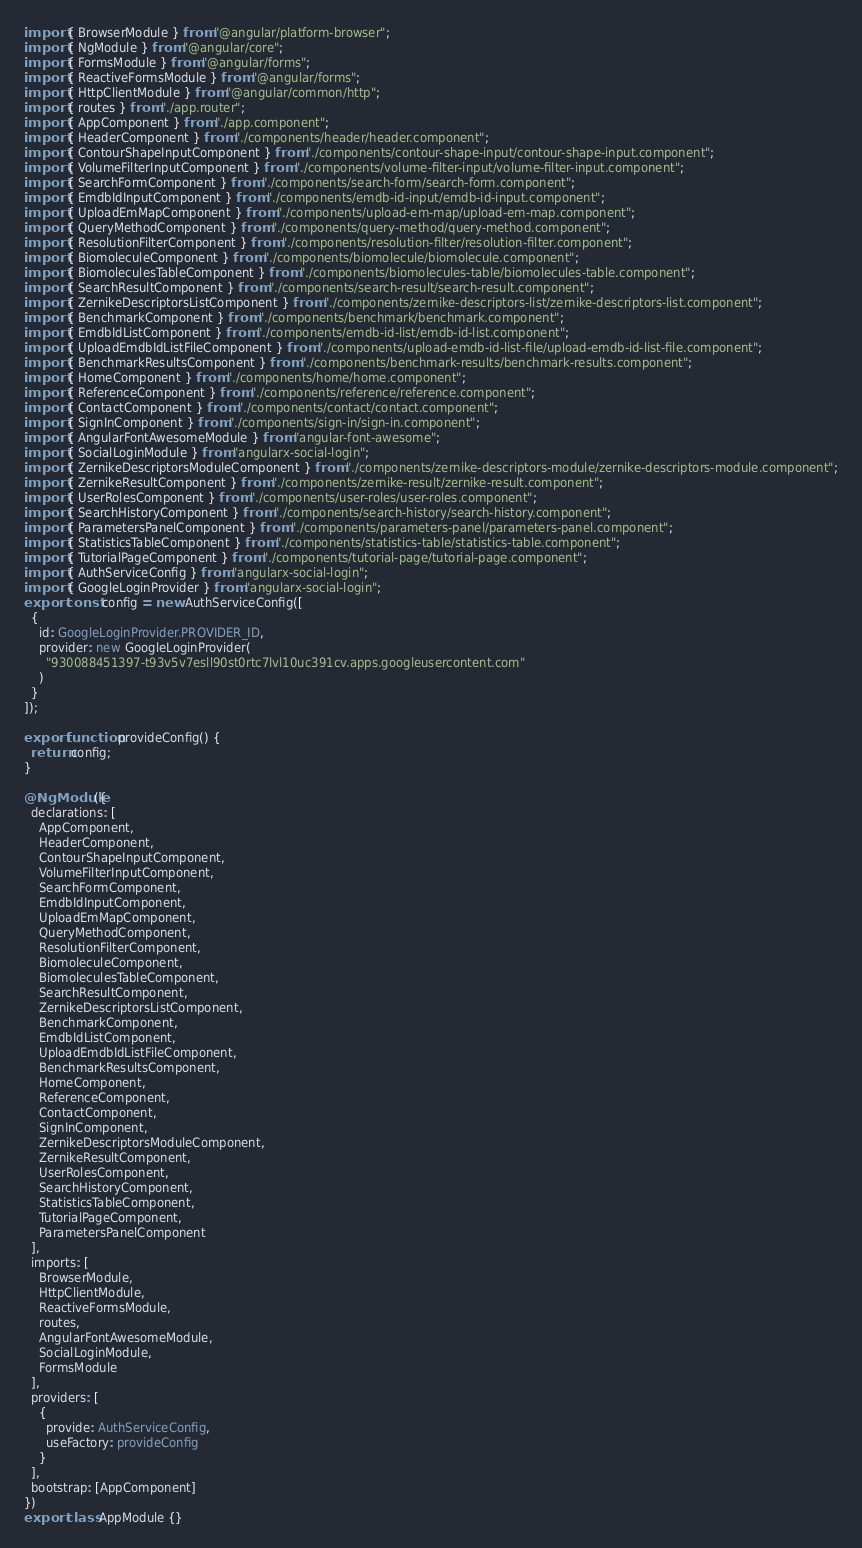Convert code to text. <code><loc_0><loc_0><loc_500><loc_500><_TypeScript_>import { BrowserModule } from "@angular/platform-browser";
import { NgModule } from "@angular/core";
import { FormsModule } from "@angular/forms";
import { ReactiveFormsModule } from "@angular/forms";
import { HttpClientModule } from "@angular/common/http";
import { routes } from "./app.router";
import { AppComponent } from "./app.component";
import { HeaderComponent } from "./components/header/header.component";
import { ContourShapeInputComponent } from "./components/contour-shape-input/contour-shape-input.component";
import { VolumeFilterInputComponent } from "./components/volume-filter-input/volume-filter-input.component";
import { SearchFormComponent } from "./components/search-form/search-form.component";
import { EmdbIdInputComponent } from "./components/emdb-id-input/emdb-id-input.component";
import { UploadEmMapComponent } from "./components/upload-em-map/upload-em-map.component";
import { QueryMethodComponent } from "./components/query-method/query-method.component";
import { ResolutionFilterComponent } from "./components/resolution-filter/resolution-filter.component";
import { BiomoleculeComponent } from "./components/biomolecule/biomolecule.component";
import { BiomoleculesTableComponent } from "./components/biomolecules-table/biomolecules-table.component";
import { SearchResultComponent } from "./components/search-result/search-result.component";
import { ZernikeDescriptorsListComponent } from "./components/zernike-descriptors-list/zernike-descriptors-list.component";
import { BenchmarkComponent } from "./components/benchmark/benchmark.component";
import { EmdbIdListComponent } from "./components/emdb-id-list/emdb-id-list.component";
import { UploadEmdbIdListFileComponent } from "./components/upload-emdb-id-list-file/upload-emdb-id-list-file.component";
import { BenchmarkResultsComponent } from "./components/benchmark-results/benchmark-results.component";
import { HomeComponent } from "./components/home/home.component";
import { ReferenceComponent } from "./components/reference/reference.component";
import { ContactComponent } from "./components/contact/contact.component";
import { SignInComponent } from "./components/sign-in/sign-in.component";
import { AngularFontAwesomeModule } from "angular-font-awesome";
import { SocialLoginModule } from "angularx-social-login";
import { ZernikeDescriptorsModuleComponent } from "./components/zernike-descriptors-module/zernike-descriptors-module.component";
import { ZernikeResultComponent } from "./components/zernike-result/zernike-result.component";
import { UserRolesComponent } from "./components/user-roles/user-roles.component";
import { SearchHistoryComponent } from "./components/search-history/search-history.component";
import { ParametersPanelComponent } from "./components/parameters-panel/parameters-panel.component";
import { StatisticsTableComponent } from "./components/statistics-table/statistics-table.component";
import { TutorialPageComponent } from "./components/tutorial-page/tutorial-page.component";
import { AuthServiceConfig } from "angularx-social-login";
import { GoogleLoginProvider } from "angularx-social-login";
export const config = new AuthServiceConfig([
  {
    id: GoogleLoginProvider.PROVIDER_ID,
    provider: new GoogleLoginProvider(
      "930088451397-t93v5v7esll90st0rtc7lvl10uc391cv.apps.googleusercontent.com"
    )
  }
]);

export function provideConfig() {
  return config;
}

@NgModule({
  declarations: [
    AppComponent,
    HeaderComponent,
    ContourShapeInputComponent,
    VolumeFilterInputComponent,
    SearchFormComponent,
    EmdbIdInputComponent,
    UploadEmMapComponent,
    QueryMethodComponent,
    ResolutionFilterComponent,
    BiomoleculeComponent,
    BiomoleculesTableComponent,
    SearchResultComponent,
    ZernikeDescriptorsListComponent,
    BenchmarkComponent,
    EmdbIdListComponent,
    UploadEmdbIdListFileComponent,
    BenchmarkResultsComponent,
    HomeComponent,
    ReferenceComponent,
    ContactComponent,
    SignInComponent,
    ZernikeDescriptorsModuleComponent,
    ZernikeResultComponent,
    UserRolesComponent,
    SearchHistoryComponent,
    StatisticsTableComponent,
    TutorialPageComponent,
    ParametersPanelComponent
  ],
  imports: [
    BrowserModule,
    HttpClientModule,
    ReactiveFormsModule,
    routes,
    AngularFontAwesomeModule,
    SocialLoginModule,
    FormsModule
  ],
  providers: [
    {
      provide: AuthServiceConfig,
      useFactory: provideConfig
    }
  ],
  bootstrap: [AppComponent]
})
export class AppModule {}
</code> 